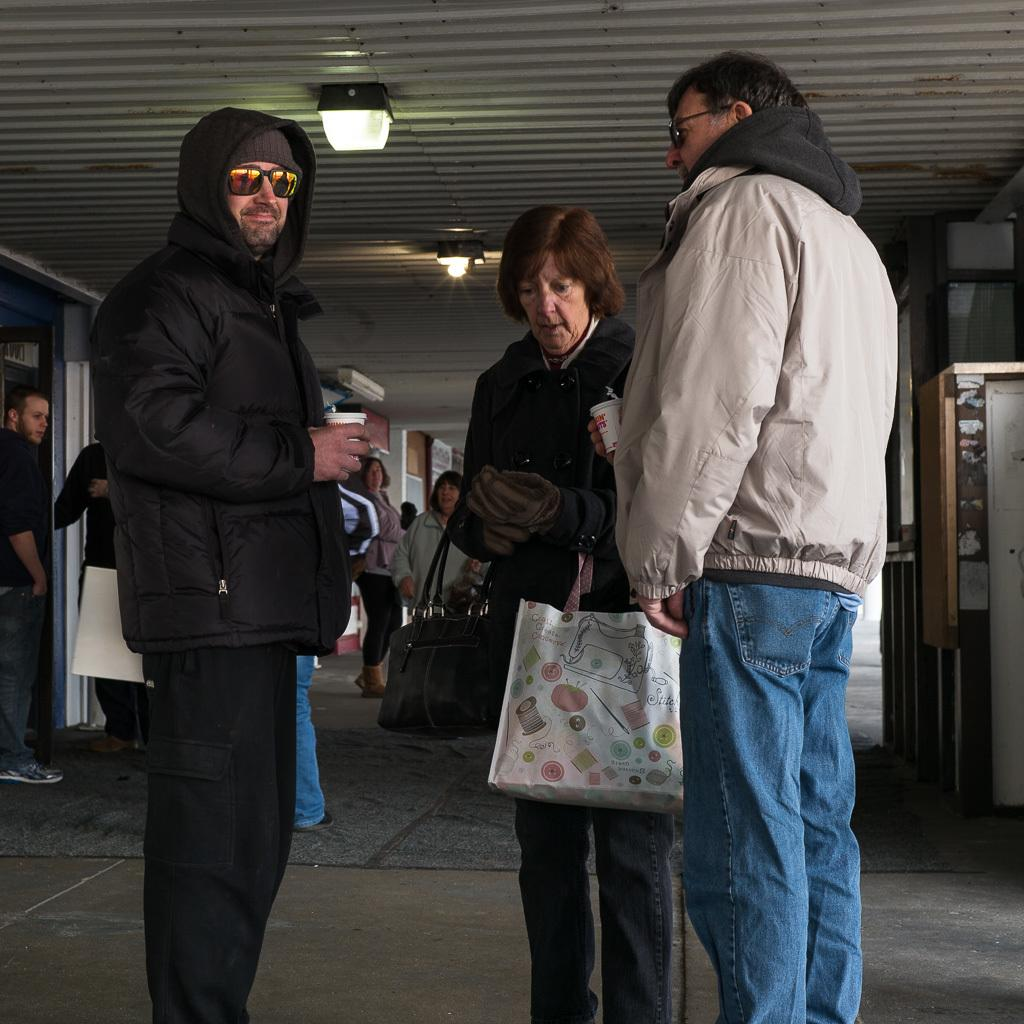How many people are in the image? There is a group of people in the image. What are some of the people holding? One person is holding bags, and two people are holding cups. What can be seen in the background of the image? There is a roof, lights, and some objects visible in the background of the image. What type of bird can be seen crying in the image? There is no bird present in the image, and therefore no such activity can be observed. 